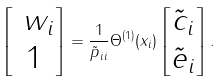<formula> <loc_0><loc_0><loc_500><loc_500>\begin{bmatrix} \ w _ { i } \\ 1 \end{bmatrix} = \frac { 1 } { \tilde { p } _ { i i } } \Theta ^ { ( 1 ) } ( x _ { i } ) \begin{bmatrix} \tilde { c } _ { i } \\ \tilde { e } _ { i } \end{bmatrix} .</formula> 